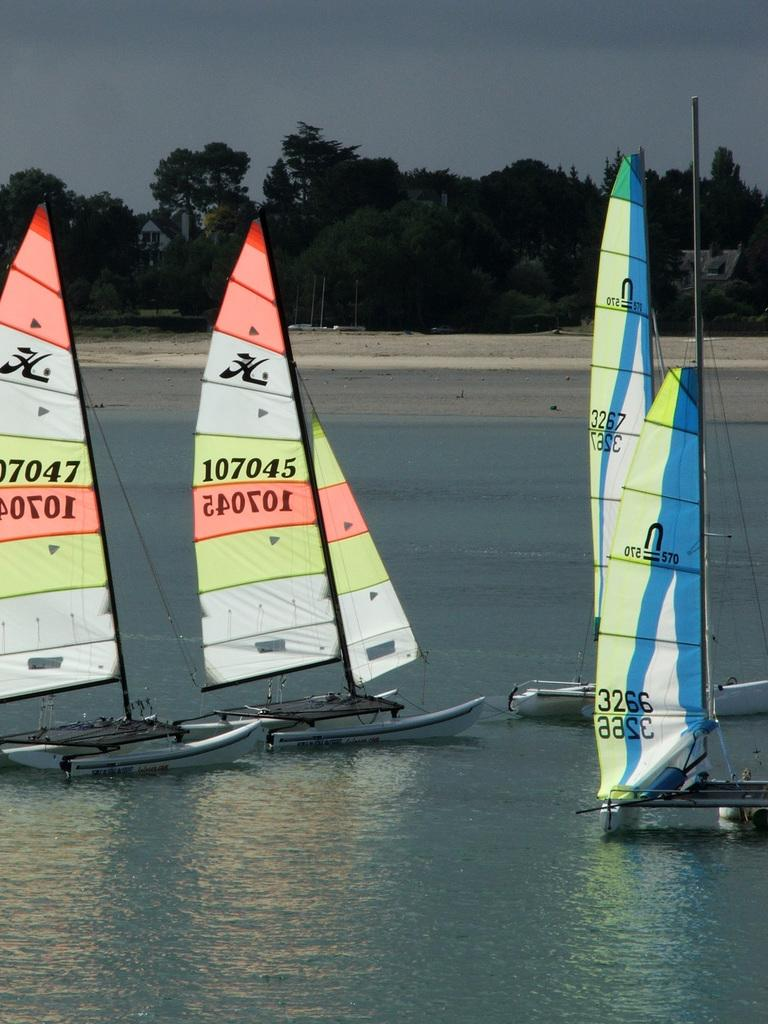<image>
Write a terse but informative summary of the picture. Four sailboats on water one says 107045 on yellow fabric and 540701 on orange fabric. 